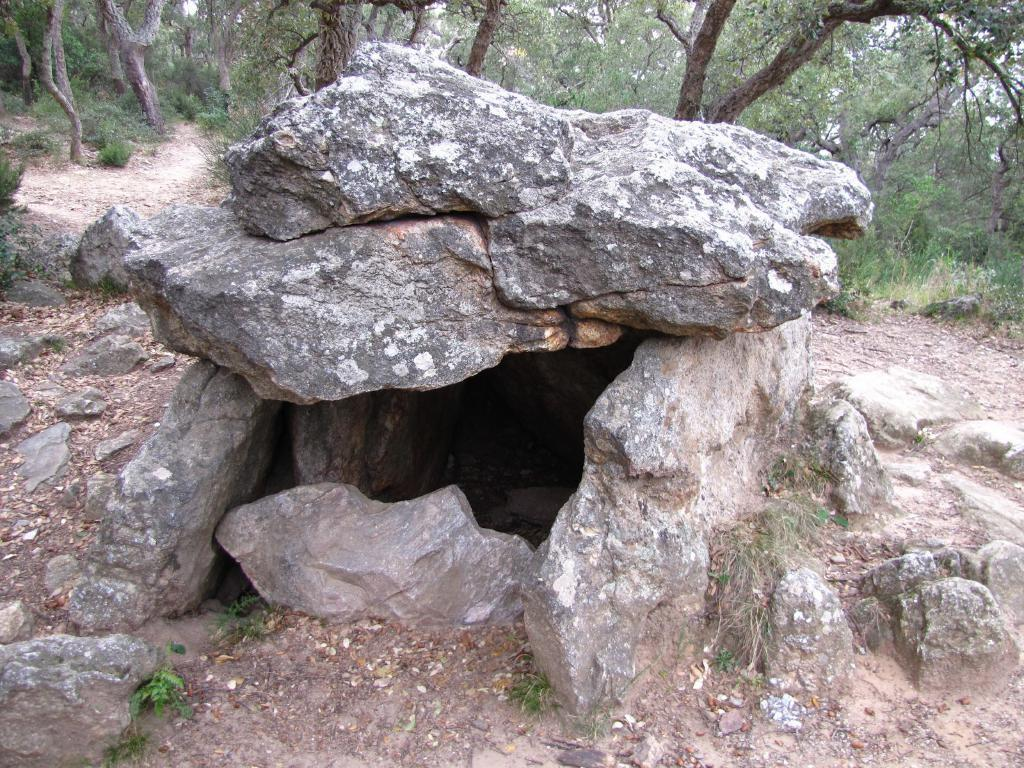What type of natural elements can be seen in the image? There are rocks, grass, trees, and plants visible in the image. What is the surface on which these natural elements are situated? The ground is visible in the image. What type of coat is the tree wearing in the image? There is no coat present on the tree in the image, as trees do not wear clothing. 